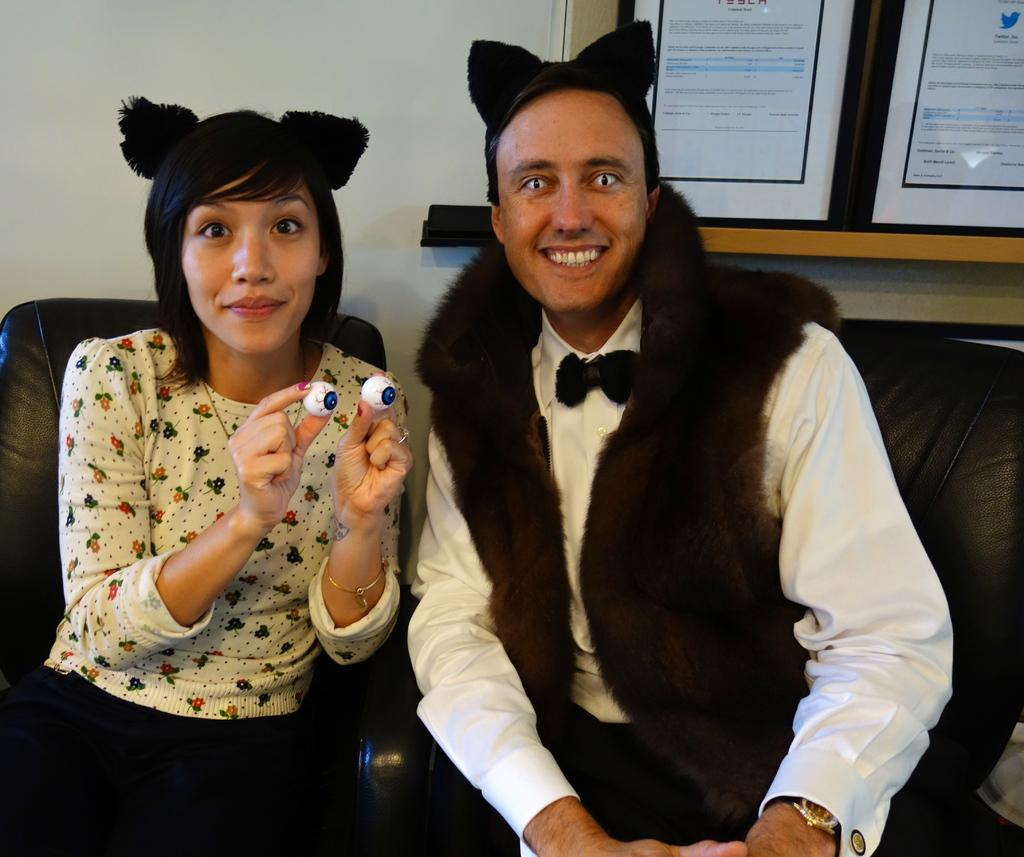How many people are sitting in the image? There are two people sitting on chairs in the image. What are the people holding? One of the people is holding objects. What can be seen behind the two people? There is a wall visible behind the two people. What is present on the wooden surface in the image? There are frames on a wooden surface in the image. What type of meal is being prepared on the sofa in the image? There is no sofa or meal preparation visible in the image. 